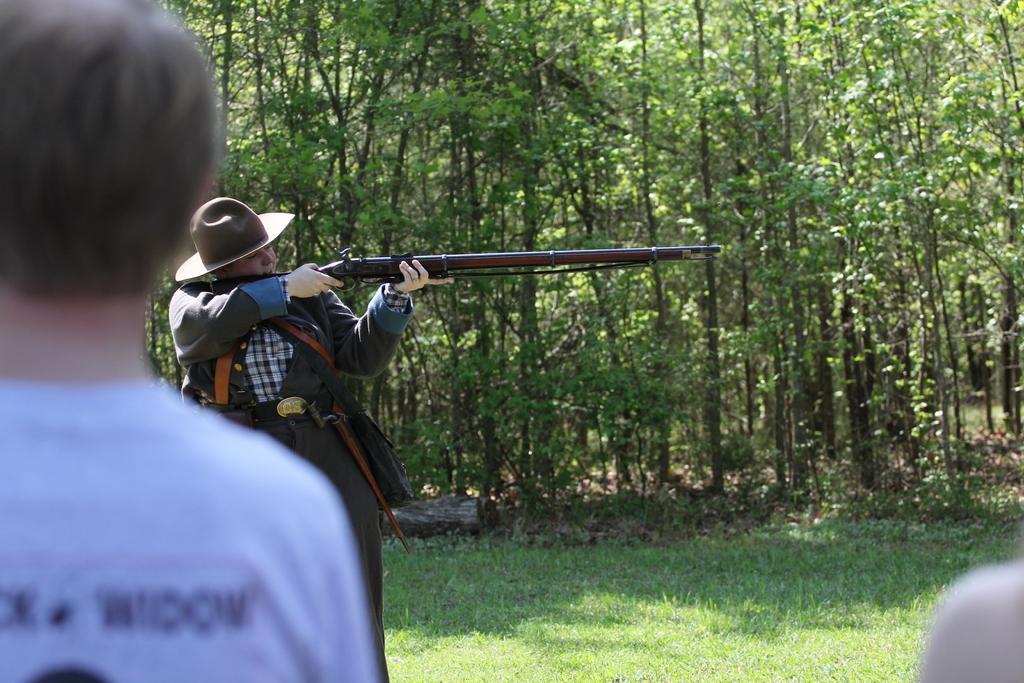Could you give a brief overview of what you see in this image? In this image, we can see a person holding gun and in the background, there are trees. In the front, there is a man standing. 